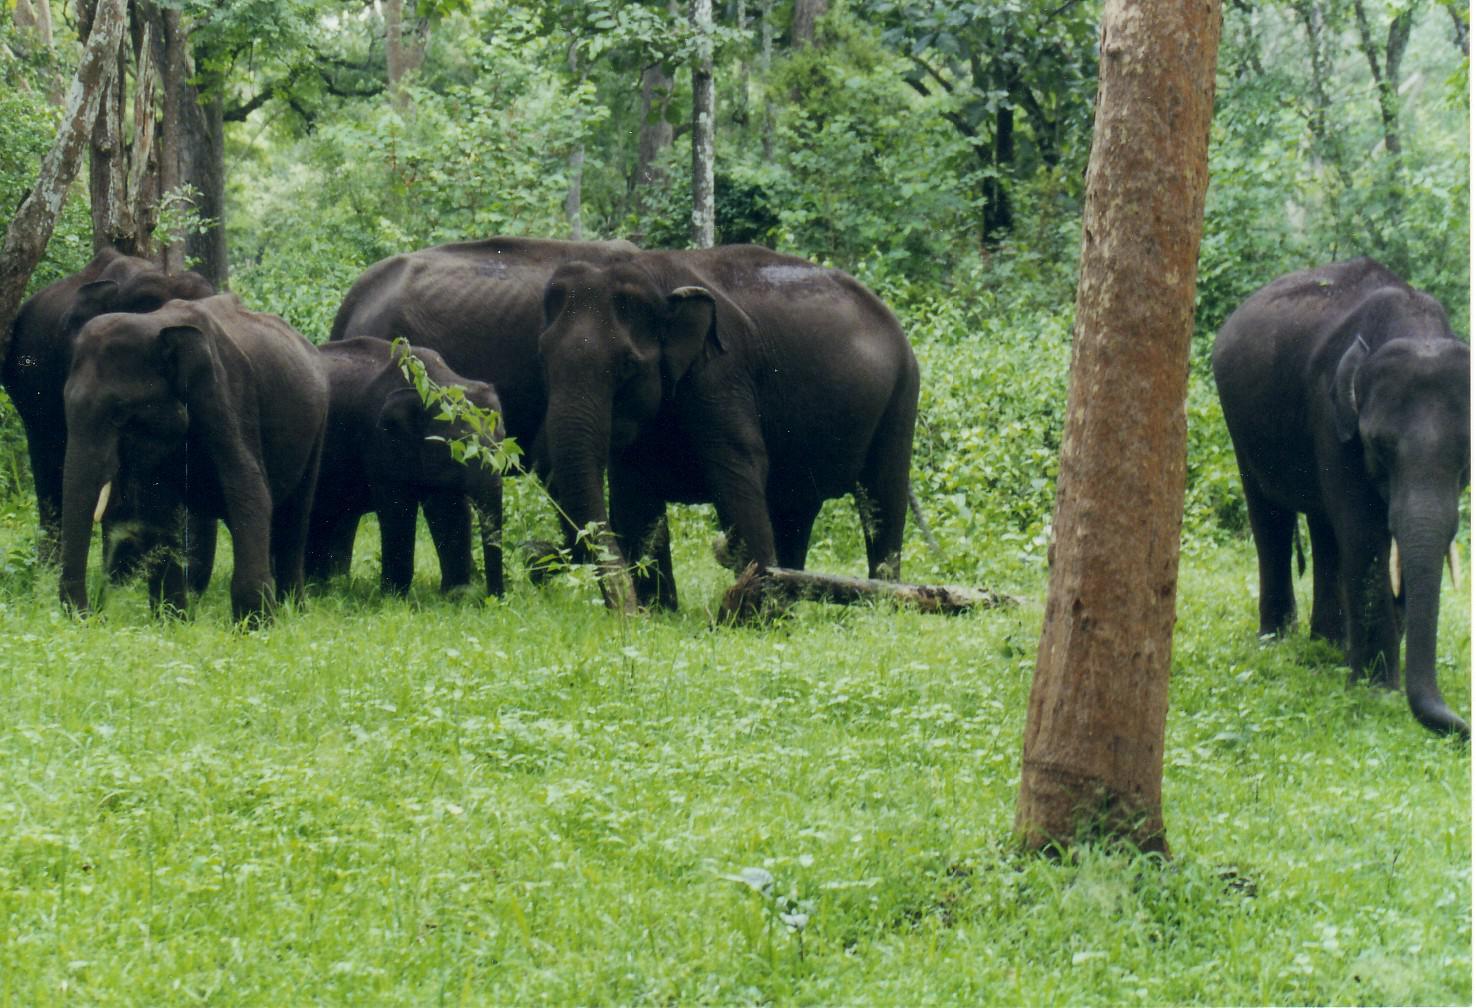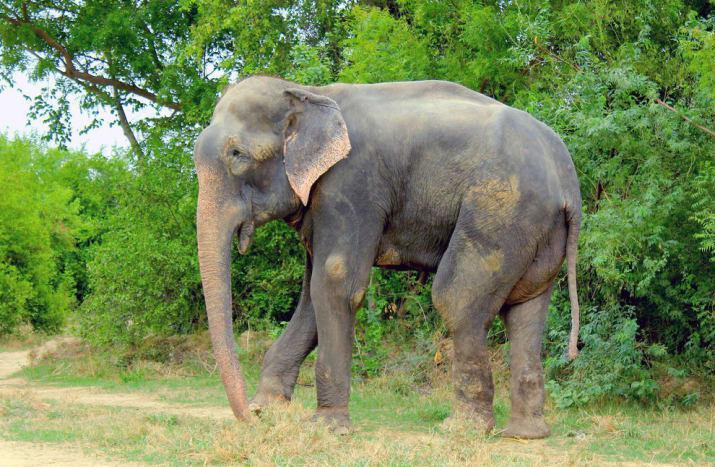The first image is the image on the left, the second image is the image on the right. Analyze the images presented: Is the assertion "There is one elephant in each image." valid? Answer yes or no. No. The first image is the image on the left, the second image is the image on the right. Given the left and right images, does the statement "There are more elephants in the image on the left." hold true? Answer yes or no. Yes. 